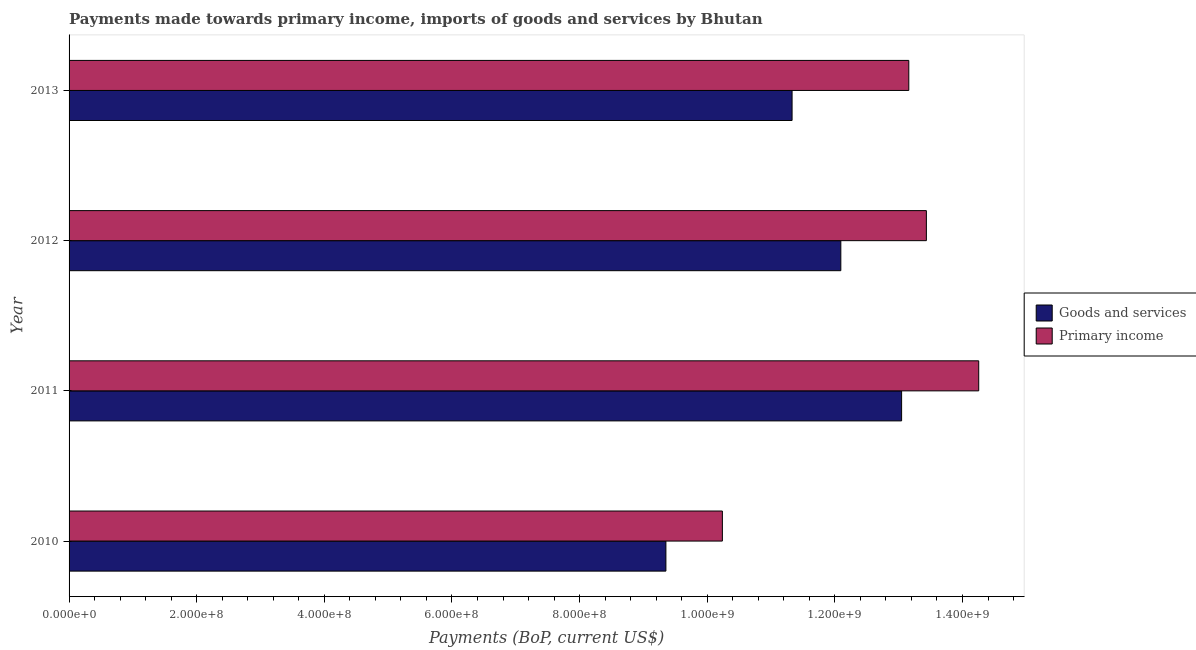How many different coloured bars are there?
Provide a succinct answer. 2. How many groups of bars are there?
Offer a terse response. 4. Are the number of bars on each tick of the Y-axis equal?
Provide a succinct answer. Yes. How many bars are there on the 1st tick from the top?
Make the answer very short. 2. What is the label of the 2nd group of bars from the top?
Offer a terse response. 2012. What is the payments made towards goods and services in 2011?
Provide a succinct answer. 1.30e+09. Across all years, what is the maximum payments made towards goods and services?
Keep it short and to the point. 1.30e+09. Across all years, what is the minimum payments made towards goods and services?
Make the answer very short. 9.35e+08. In which year was the payments made towards goods and services minimum?
Give a very brief answer. 2010. What is the total payments made towards goods and services in the graph?
Offer a very short reply. 4.58e+09. What is the difference between the payments made towards primary income in 2010 and that in 2013?
Your response must be concise. -2.92e+08. What is the difference between the payments made towards goods and services in 2010 and the payments made towards primary income in 2013?
Keep it short and to the point. -3.81e+08. What is the average payments made towards goods and services per year?
Give a very brief answer. 1.15e+09. In the year 2010, what is the difference between the payments made towards primary income and payments made towards goods and services?
Your answer should be compact. 8.85e+07. What is the ratio of the payments made towards goods and services in 2011 to that in 2013?
Give a very brief answer. 1.15. What is the difference between the highest and the second highest payments made towards primary income?
Ensure brevity in your answer.  8.20e+07. What is the difference between the highest and the lowest payments made towards primary income?
Keep it short and to the point. 4.02e+08. What does the 2nd bar from the top in 2012 represents?
Offer a very short reply. Goods and services. What does the 2nd bar from the bottom in 2011 represents?
Your answer should be very brief. Primary income. Are the values on the major ticks of X-axis written in scientific E-notation?
Provide a short and direct response. Yes. Where does the legend appear in the graph?
Provide a short and direct response. Center right. How are the legend labels stacked?
Keep it short and to the point. Vertical. What is the title of the graph?
Keep it short and to the point. Payments made towards primary income, imports of goods and services by Bhutan. What is the label or title of the X-axis?
Keep it short and to the point. Payments (BoP, current US$). What is the Payments (BoP, current US$) of Goods and services in 2010?
Make the answer very short. 9.35e+08. What is the Payments (BoP, current US$) of Primary income in 2010?
Your answer should be very brief. 1.02e+09. What is the Payments (BoP, current US$) of Goods and services in 2011?
Offer a terse response. 1.30e+09. What is the Payments (BoP, current US$) of Primary income in 2011?
Keep it short and to the point. 1.43e+09. What is the Payments (BoP, current US$) in Goods and services in 2012?
Provide a succinct answer. 1.21e+09. What is the Payments (BoP, current US$) in Primary income in 2012?
Offer a very short reply. 1.34e+09. What is the Payments (BoP, current US$) of Goods and services in 2013?
Your answer should be very brief. 1.13e+09. What is the Payments (BoP, current US$) of Primary income in 2013?
Offer a terse response. 1.32e+09. Across all years, what is the maximum Payments (BoP, current US$) in Goods and services?
Make the answer very short. 1.30e+09. Across all years, what is the maximum Payments (BoP, current US$) in Primary income?
Keep it short and to the point. 1.43e+09. Across all years, what is the minimum Payments (BoP, current US$) in Goods and services?
Provide a short and direct response. 9.35e+08. Across all years, what is the minimum Payments (BoP, current US$) of Primary income?
Your answer should be compact. 1.02e+09. What is the total Payments (BoP, current US$) in Goods and services in the graph?
Provide a short and direct response. 4.58e+09. What is the total Payments (BoP, current US$) of Primary income in the graph?
Offer a terse response. 5.11e+09. What is the difference between the Payments (BoP, current US$) in Goods and services in 2010 and that in 2011?
Provide a succinct answer. -3.69e+08. What is the difference between the Payments (BoP, current US$) in Primary income in 2010 and that in 2011?
Keep it short and to the point. -4.02e+08. What is the difference between the Payments (BoP, current US$) in Goods and services in 2010 and that in 2012?
Your answer should be very brief. -2.74e+08. What is the difference between the Payments (BoP, current US$) in Primary income in 2010 and that in 2012?
Keep it short and to the point. -3.20e+08. What is the difference between the Payments (BoP, current US$) in Goods and services in 2010 and that in 2013?
Offer a very short reply. -1.98e+08. What is the difference between the Payments (BoP, current US$) in Primary income in 2010 and that in 2013?
Your answer should be compact. -2.92e+08. What is the difference between the Payments (BoP, current US$) in Goods and services in 2011 and that in 2012?
Your response must be concise. 9.52e+07. What is the difference between the Payments (BoP, current US$) of Primary income in 2011 and that in 2012?
Your answer should be compact. 8.20e+07. What is the difference between the Payments (BoP, current US$) in Goods and services in 2011 and that in 2013?
Give a very brief answer. 1.72e+08. What is the difference between the Payments (BoP, current US$) in Primary income in 2011 and that in 2013?
Give a very brief answer. 1.10e+08. What is the difference between the Payments (BoP, current US$) of Goods and services in 2012 and that in 2013?
Make the answer very short. 7.64e+07. What is the difference between the Payments (BoP, current US$) in Primary income in 2012 and that in 2013?
Your answer should be very brief. 2.76e+07. What is the difference between the Payments (BoP, current US$) of Goods and services in 2010 and the Payments (BoP, current US$) of Primary income in 2011?
Your answer should be very brief. -4.90e+08. What is the difference between the Payments (BoP, current US$) of Goods and services in 2010 and the Payments (BoP, current US$) of Primary income in 2012?
Keep it short and to the point. -4.08e+08. What is the difference between the Payments (BoP, current US$) in Goods and services in 2010 and the Payments (BoP, current US$) in Primary income in 2013?
Your response must be concise. -3.81e+08. What is the difference between the Payments (BoP, current US$) in Goods and services in 2011 and the Payments (BoP, current US$) in Primary income in 2012?
Offer a terse response. -3.88e+07. What is the difference between the Payments (BoP, current US$) in Goods and services in 2011 and the Payments (BoP, current US$) in Primary income in 2013?
Ensure brevity in your answer.  -1.13e+07. What is the difference between the Payments (BoP, current US$) in Goods and services in 2012 and the Payments (BoP, current US$) in Primary income in 2013?
Give a very brief answer. -1.07e+08. What is the average Payments (BoP, current US$) of Goods and services per year?
Your response must be concise. 1.15e+09. What is the average Payments (BoP, current US$) in Primary income per year?
Your response must be concise. 1.28e+09. In the year 2010, what is the difference between the Payments (BoP, current US$) of Goods and services and Payments (BoP, current US$) of Primary income?
Keep it short and to the point. -8.85e+07. In the year 2011, what is the difference between the Payments (BoP, current US$) of Goods and services and Payments (BoP, current US$) of Primary income?
Keep it short and to the point. -1.21e+08. In the year 2012, what is the difference between the Payments (BoP, current US$) in Goods and services and Payments (BoP, current US$) in Primary income?
Provide a short and direct response. -1.34e+08. In the year 2013, what is the difference between the Payments (BoP, current US$) of Goods and services and Payments (BoP, current US$) of Primary income?
Your answer should be compact. -1.83e+08. What is the ratio of the Payments (BoP, current US$) in Goods and services in 2010 to that in 2011?
Provide a succinct answer. 0.72. What is the ratio of the Payments (BoP, current US$) of Primary income in 2010 to that in 2011?
Offer a very short reply. 0.72. What is the ratio of the Payments (BoP, current US$) in Goods and services in 2010 to that in 2012?
Your answer should be compact. 0.77. What is the ratio of the Payments (BoP, current US$) in Primary income in 2010 to that in 2012?
Provide a succinct answer. 0.76. What is the ratio of the Payments (BoP, current US$) of Goods and services in 2010 to that in 2013?
Ensure brevity in your answer.  0.83. What is the ratio of the Payments (BoP, current US$) of Primary income in 2010 to that in 2013?
Provide a succinct answer. 0.78. What is the ratio of the Payments (BoP, current US$) in Goods and services in 2011 to that in 2012?
Offer a terse response. 1.08. What is the ratio of the Payments (BoP, current US$) of Primary income in 2011 to that in 2012?
Keep it short and to the point. 1.06. What is the ratio of the Payments (BoP, current US$) in Goods and services in 2011 to that in 2013?
Keep it short and to the point. 1.15. What is the ratio of the Payments (BoP, current US$) in Primary income in 2011 to that in 2013?
Offer a very short reply. 1.08. What is the ratio of the Payments (BoP, current US$) in Goods and services in 2012 to that in 2013?
Ensure brevity in your answer.  1.07. What is the ratio of the Payments (BoP, current US$) of Primary income in 2012 to that in 2013?
Your response must be concise. 1.02. What is the difference between the highest and the second highest Payments (BoP, current US$) of Goods and services?
Give a very brief answer. 9.52e+07. What is the difference between the highest and the second highest Payments (BoP, current US$) in Primary income?
Offer a terse response. 8.20e+07. What is the difference between the highest and the lowest Payments (BoP, current US$) of Goods and services?
Your response must be concise. 3.69e+08. What is the difference between the highest and the lowest Payments (BoP, current US$) in Primary income?
Give a very brief answer. 4.02e+08. 